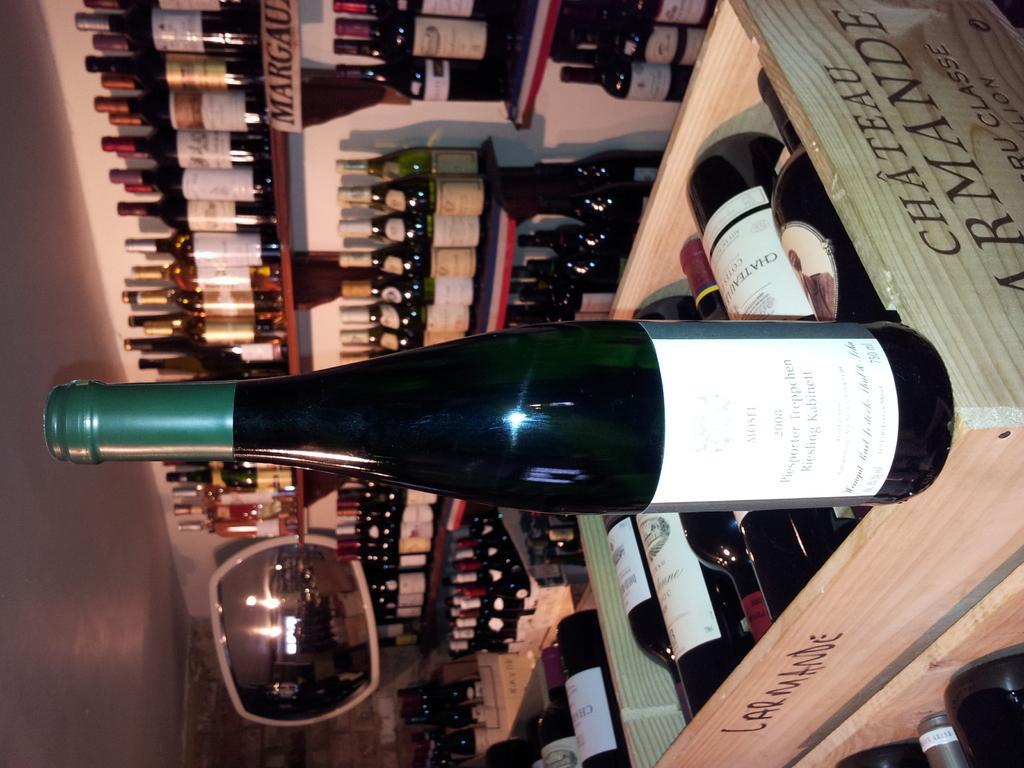Please provide a concise description of this image. In the foreground, I can see liquor bottles in wooden boxes and in shelves. In the background, I can see a wall, mirror and some objects. This image taken, maybe in a shop. 